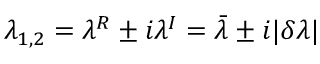Convert formula to latex. <formula><loc_0><loc_0><loc_500><loc_500>\lambda _ { 1 , 2 } = \lambda ^ { R } \pm i \lambda ^ { I } = \bar { \lambda } \pm i | \delta \lambda |</formula> 